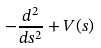<formula> <loc_0><loc_0><loc_500><loc_500>- \frac { d ^ { 2 } } { d s ^ { 2 } } + V ( s )</formula> 